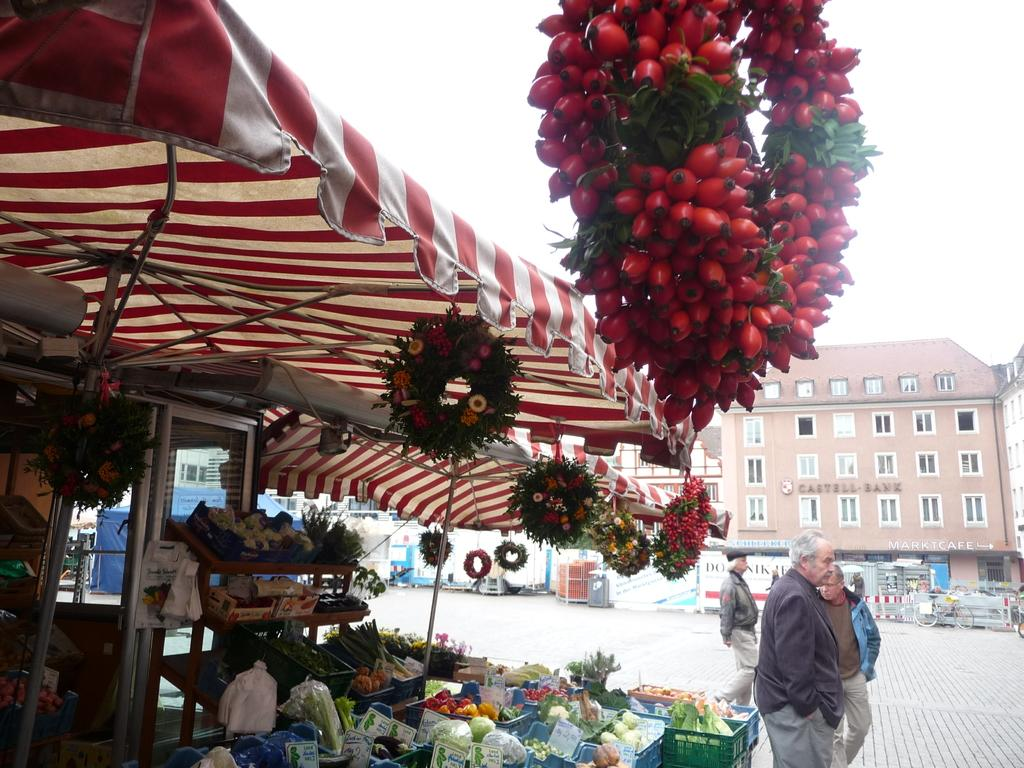What type of structures can be seen in the image? There are buildings in the image. What mode of transportation is present in the image? There is a vehicle in the image. What temporary shelter is visible in the image? There is a tent in the image. What type of establishment can be found in the image? There is a store in the image. What type of containers are present in the image? There are baskets in the image. Are there any living beings in the image? Yes, there are people in the image. What part of the natural environment is visible in the image? The sky is visible in the image. What type of long, thin objects can be seen in the image? There are rods in the image. What type of storage or display structures are present in the image? There are racks in the image. What type of food items are visible in the image? There are vegetables in the image. Can you describe any other objects present in the image? There are other objects in the image, but their specific details are not mentioned in the provided facts. Can you tell me how many frogs are sitting on the rods in the image? There are no frogs present in the image; only buildings, a vehicle, a tent, a store, baskets, people, the sky, rods, racks, and vegetables are mentioned. What type of gardening tool is being used by the people in the image? There is no gardening tool, such as a spade, present in the image. 